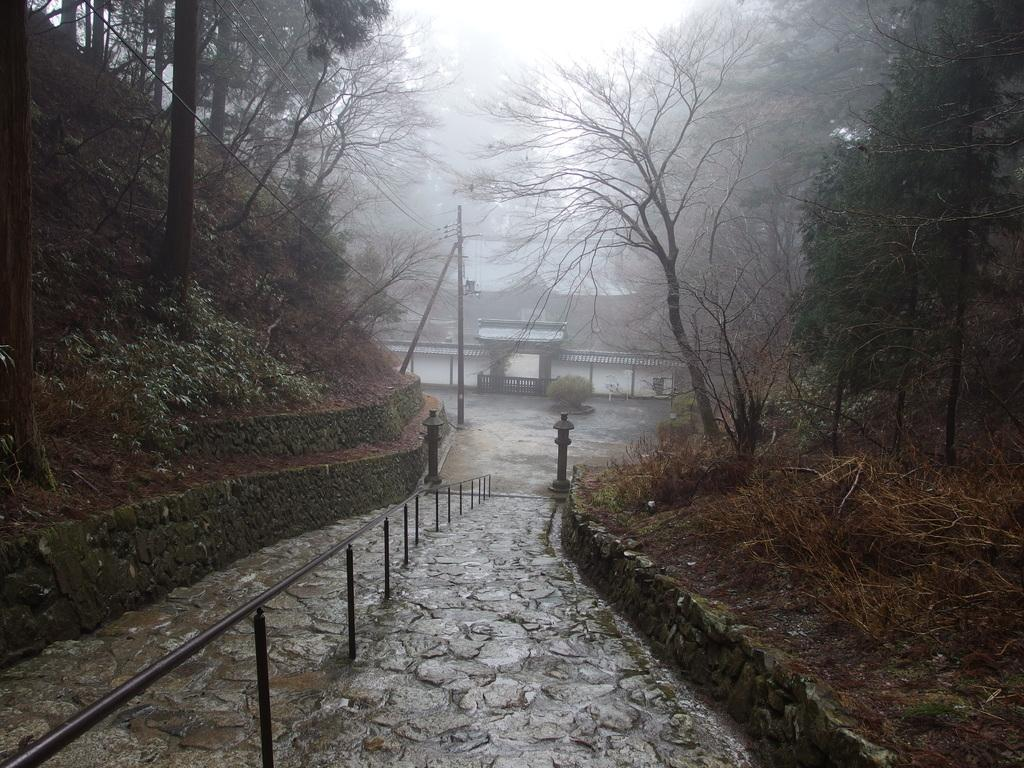What can be seen in the image that people might walk on? There is a path in the image that people might walk on. What type of vegetation is present alongside the path? There are trees on either side of the path. What structure can be seen in the distance in the image? There is a house in the background of the image. What type of work is being discussed in the image? There is no indication of any work or discussion in the image; it primarily features a path, trees, and a house in the background. 